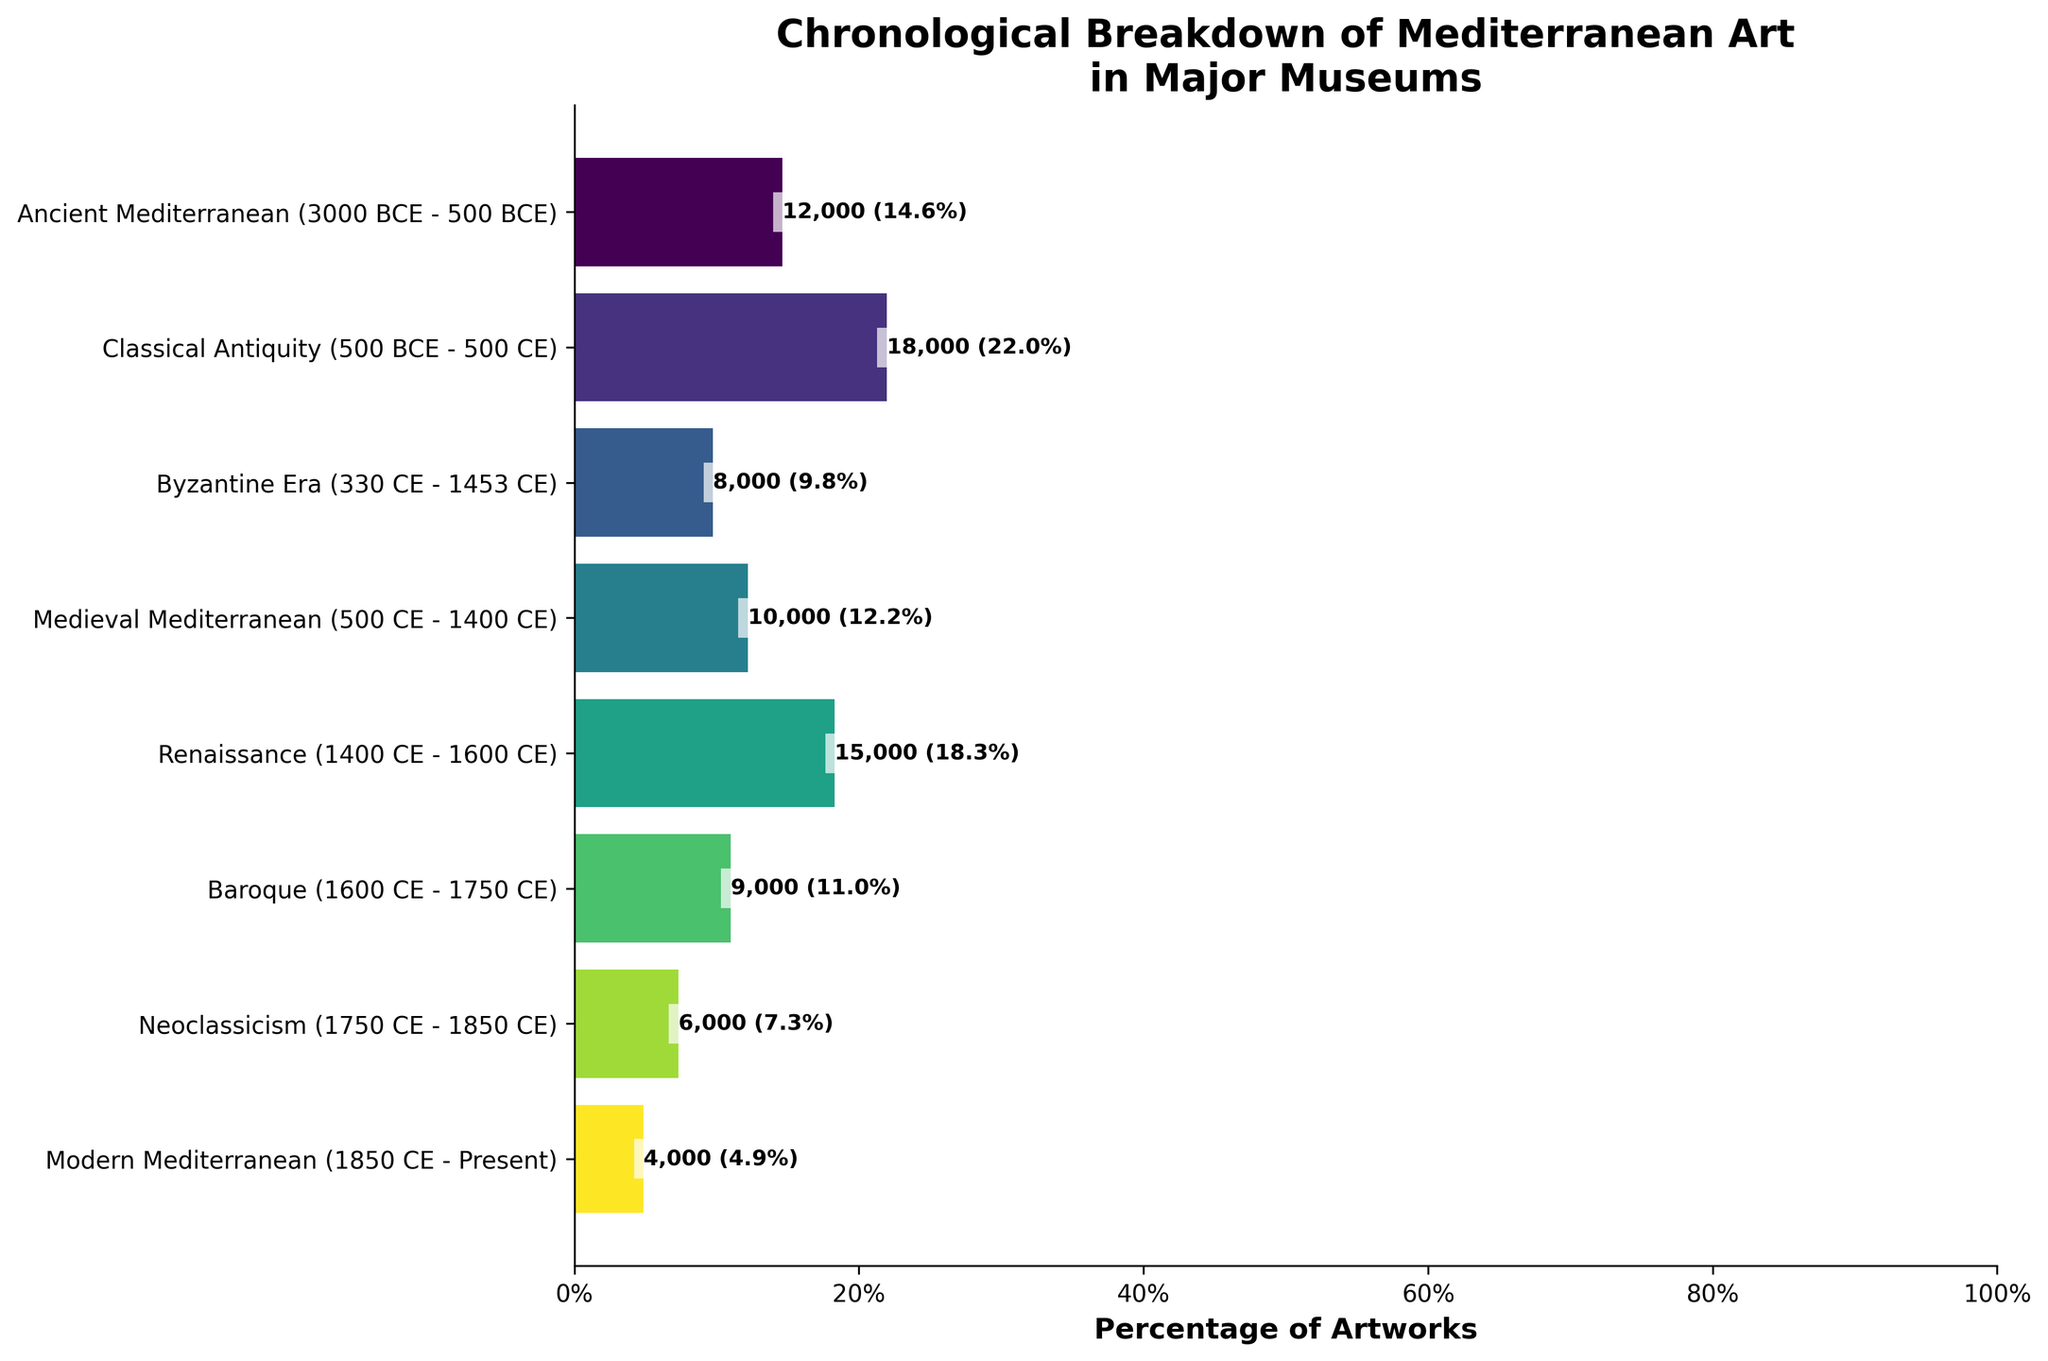Which historical period has the most artworks displayed in major museums? The period with the longest bar and the highest percentage label represents the most artworks. In this case, it is "Classical Antiquity (500 BCE - 500 CE)."
Answer: Classical Antiquity What percentage of artworks in major museums come from the Renaissance period? Locate the bar labeled "Renaissance (1400 CE - 1600 CE)" and read the percentage shown alongside the number of artworks.
Answer: 18.8% How many artworks from the Byzantine Era are displayed in major museums? Identify the "Byzantine Era (330 CE - 1453 CE)" bar and read the number of artworks next to it.
Answer: 8,000 Which period has a higher percentage of artworks, Medieval Mediterranean or Baroque? Compare the percentage labels next to the "Medieval Mediterranean (500 CE - 1400 CE)" and "Baroque (1600 CE - 1750 CE)" bars.
Answer: Medieval Mediterranean What is the total number of artworks from the periods before the Renaissance? Sum the artwork numbers for Ancient Mediterranean, Classical Antiquity, Byzantine Era, and Medieval Mediterranean: 12,000 + 18,000 + 8,000 + 10,000 = 48,000.
Answer: 48,000 Is the number of artworks from Modern Mediterranean greater than the number from Neoclassicism? Compare the artwork counts labeled next to "Modern Mediterranean (1850 CE - Present)" and "Neoclassicism (1750 CE - 1850 CE)" bars.
Answer: No What is the combined percentage of artworks from the Baroque and Neoclassicism periods? Add the percentages from the "Baroque (1600 CE - 1750 CE)" and "Neoclassicism (1750 CE - 1850 CE)" periods: 11.3% + 7.5% = 18.8%.
Answer: 18.8% How does the number of artworks from Classical Antiquity compare to the sum of artworks from Baroque and Modern Mediterranean periods? Classical Antiquity: 18,000. Sum of Baroque (9,000) and Modern Mediterranean (4,000): 13,000. Classical Antiquity has more.
Answer: More What period directly follows the Byzantine Era in the period breakdown? Check the sequence of periods in the funnel chart. The period after "Byzantine Era" is "Medieval Mediterranean."
Answer: Medieval Mediterranean What is the approximate difference in the number of artworks between Ancient Mediterranean and Renaissance periods? Subtract the number of artworks in "Ancient Mediterranean (12,000)" from "Renaissance (15,000)": 15,000 - 12,000 = 3,000.
Answer: 3,000 